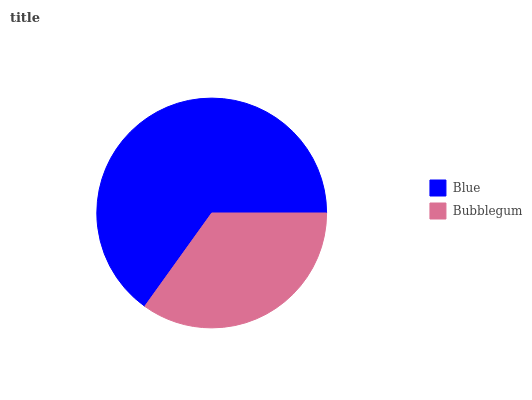Is Bubblegum the minimum?
Answer yes or no. Yes. Is Blue the maximum?
Answer yes or no. Yes. Is Bubblegum the maximum?
Answer yes or no. No. Is Blue greater than Bubblegum?
Answer yes or no. Yes. Is Bubblegum less than Blue?
Answer yes or no. Yes. Is Bubblegum greater than Blue?
Answer yes or no. No. Is Blue less than Bubblegum?
Answer yes or no. No. Is Blue the high median?
Answer yes or no. Yes. Is Bubblegum the low median?
Answer yes or no. Yes. Is Bubblegum the high median?
Answer yes or no. No. Is Blue the low median?
Answer yes or no. No. 